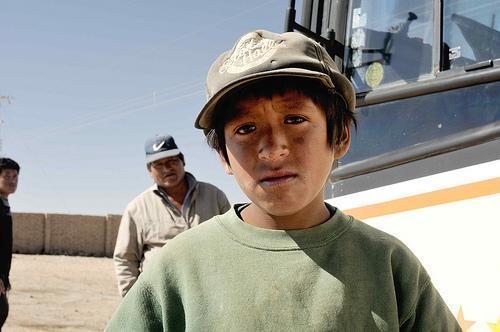How many men are pictured here?
Give a very brief answer. 3. How many women are in this picture?
Give a very brief answer. 0. 